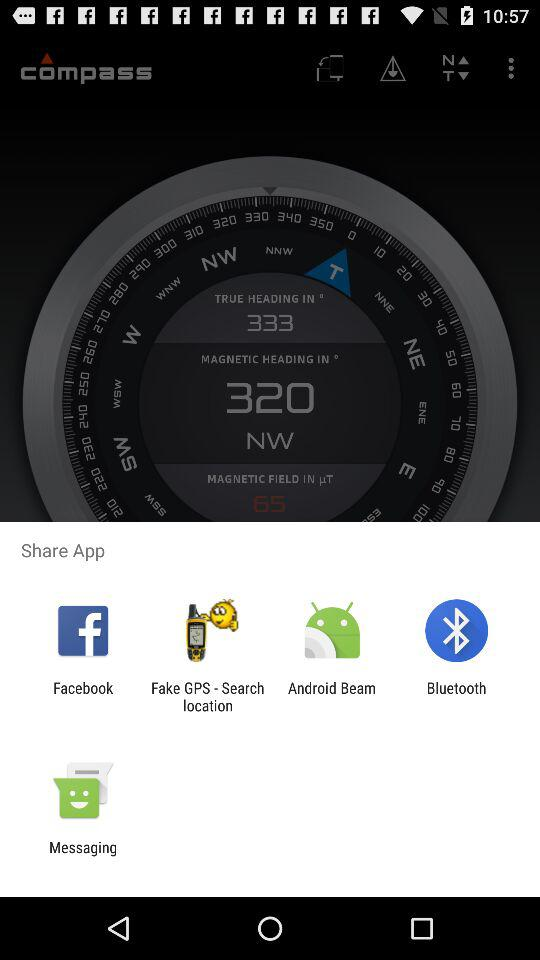Through which app can we share? You can share through "Facebook", "Fake GPS - Search location", "Android Beam", "Bluetooth" and "Messaging". 